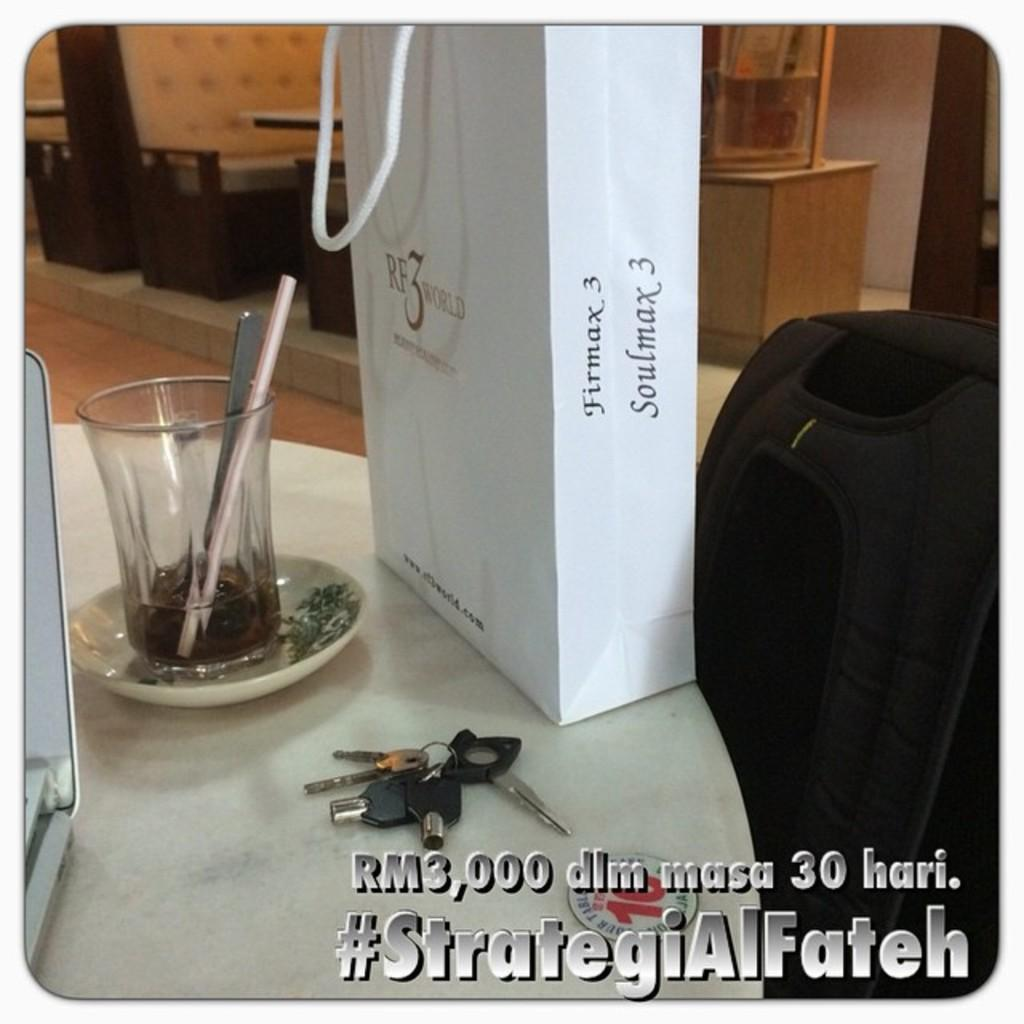<image>
Provide a brief description of the given image. A white shopping bag from Firmax 3 sits next to a mostly empty class on a table. 